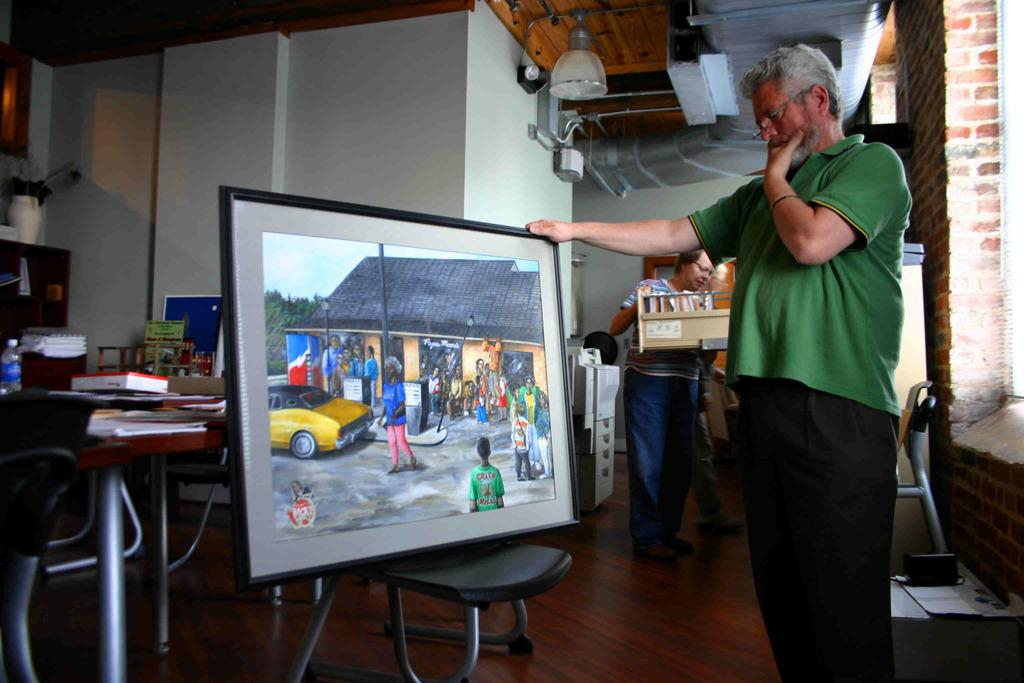What is the man in the image doing? The man is standing and holding a photo frame. Can you describe the other person in the image? The other person is also standing and holding a tray box. What might the man and the other person be doing together? They might be preparing for an event or organizing items. What type of knot is the man tying in the image? There is no knot present in the image; the man is holding a photo frame. What ornament is hanging from the ceiling in the image? There is no ornament hanging from the ceiling in the image. 